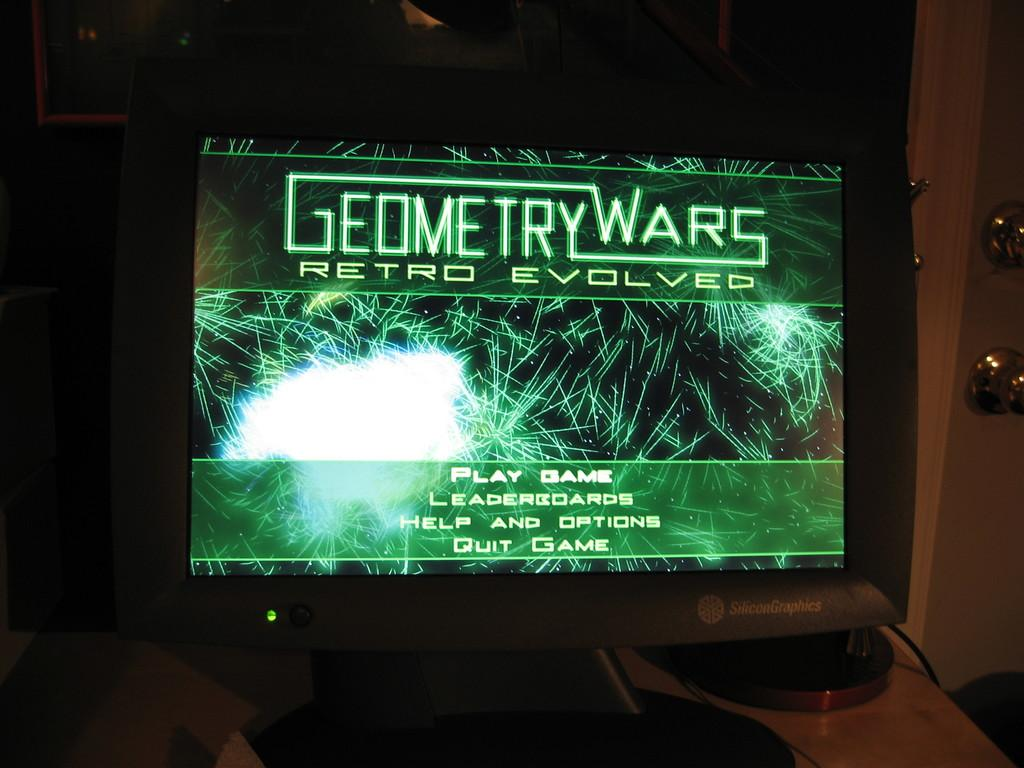What is being displayed on the computer monitor in the image? There is a game on a computer monitor in the image. Where is the computer monitor located? The computer monitor is on a table. What type of toy is being used by the porter in the image? There is no porter or toy present in the image. 